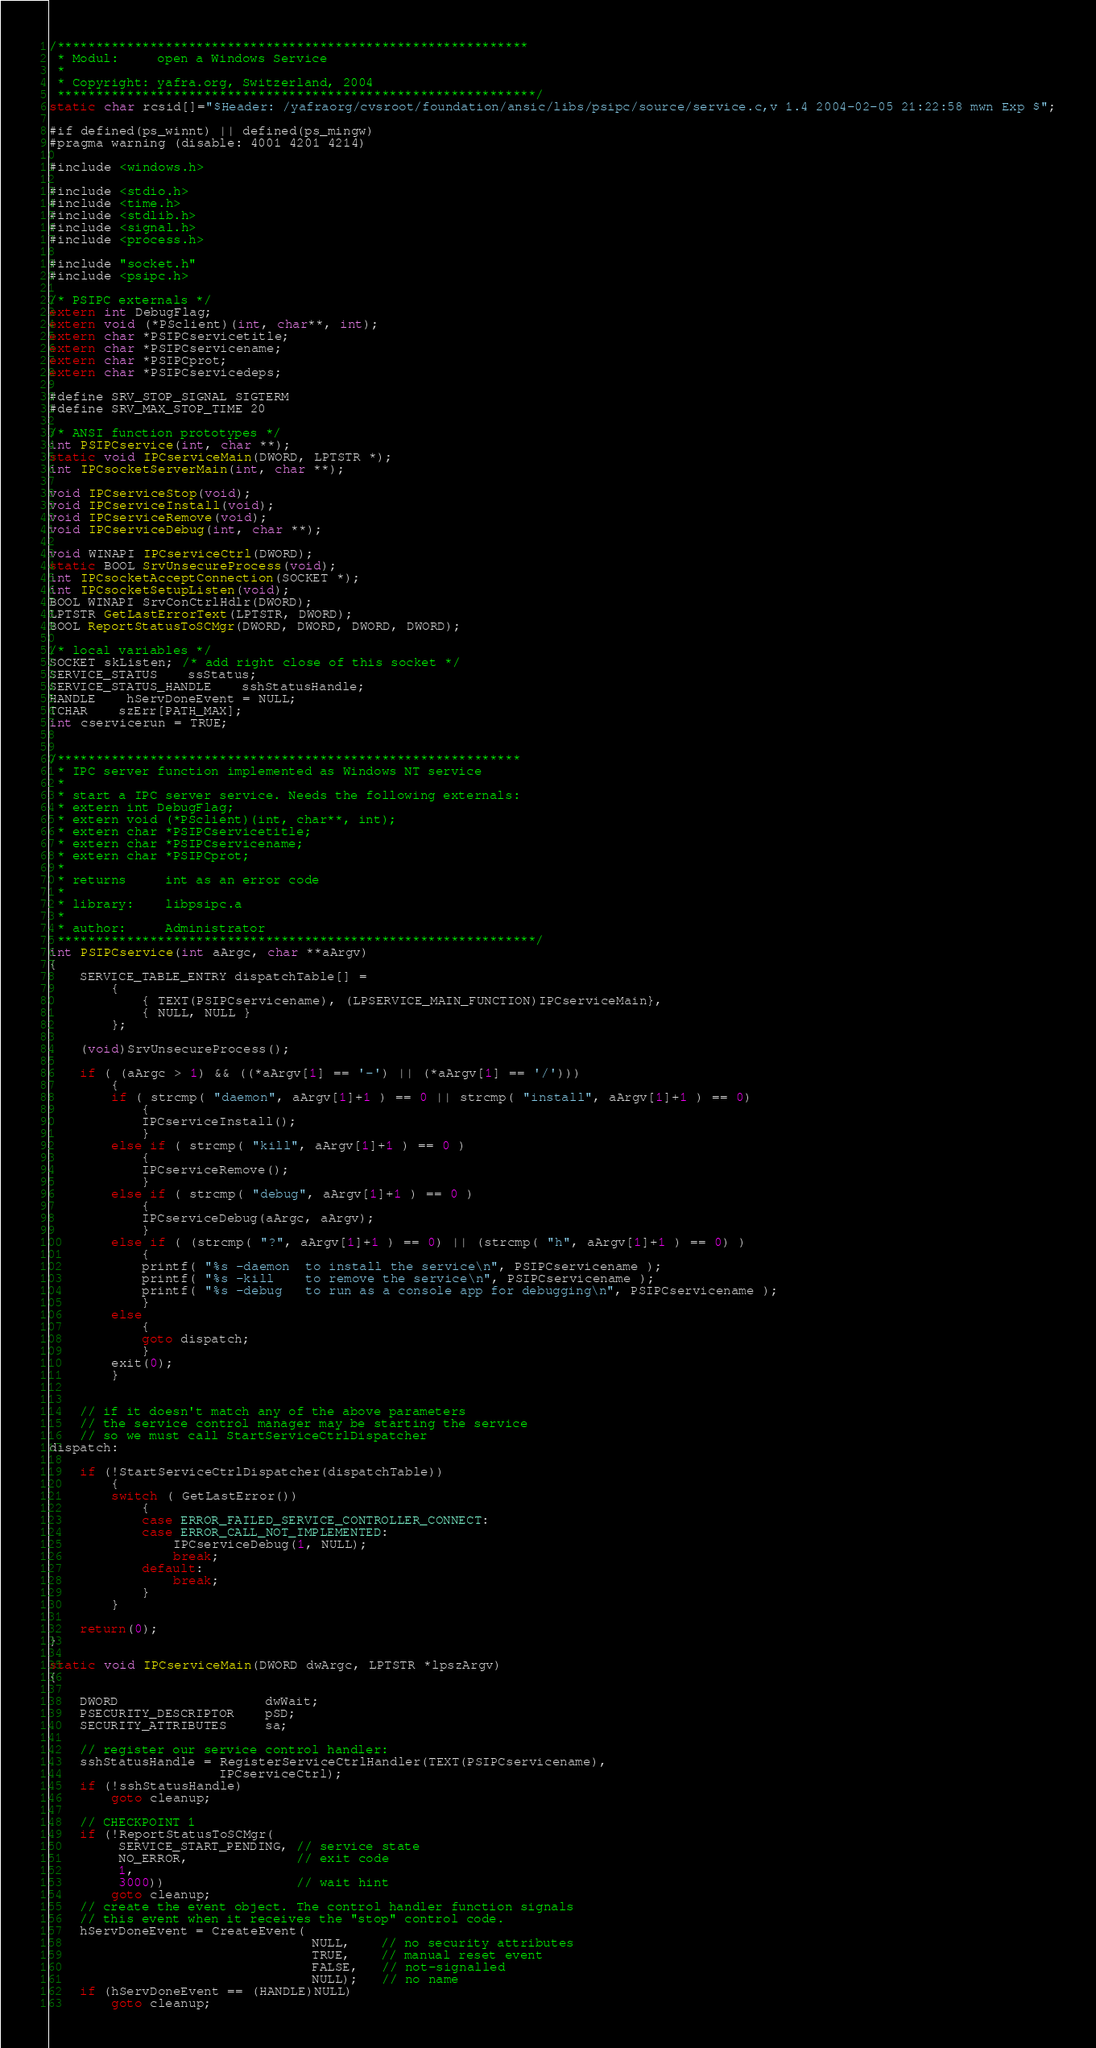Convert code to text. <code><loc_0><loc_0><loc_500><loc_500><_C_>/*************************************************************
 * Modul:     open a Windows Service
 *
 * Copyright: yafra.org, Switzerland, 2004
 **************************************************************/
static char rcsid[]="$Header: /yafraorg/cvsroot/foundation/ansic/libs/psipc/source/service.c,v 1.4 2004-02-05 21:22:58 mwn Exp $";

#if defined(ps_winnt) || defined(ps_mingw)
#pragma warning (disable: 4001 4201 4214)

#include <windows.h>

#include <stdio.h>
#include <time.h>
#include <stdlib.h>
#include <signal.h>
#include <process.h>

#include "socket.h"
#include <psipc.h>

/* PSIPC externals */
extern int DebugFlag;
extern void (*PSclient)(int, char**, int);
extern char *PSIPCservicetitle;
extern char *PSIPCservicename;
extern char *PSIPCprot;
extern char *PSIPCservicedeps;

#define SRV_STOP_SIGNAL SIGTERM
#define SRV_MAX_STOP_TIME 20

/* ANSI function prototypes */
int PSIPCservice(int, char **);
static void IPCserviceMain(DWORD, LPTSTR *);
int IPCsocketServerMain(int, char **);

void IPCserviceStop(void);
void IPCserviceInstall(void);
void IPCserviceRemove(void);
void IPCserviceDebug(int, char **);

void WINAPI IPCserviceCtrl(DWORD);
static BOOL SrvUnsecureProcess(void);
int IPCsocketAcceptConnection(SOCKET *);
int IPCsocketSetupListen(void);
BOOL WINAPI SrvConCtrlHdlr(DWORD);
LPTSTR GetLastErrorText(LPTSTR, DWORD);
BOOL ReportStatusToSCMgr(DWORD, DWORD, DWORD, DWORD);

/* local variables */
SOCKET skListen; /* add right close of this socket */
SERVICE_STATUS	ssStatus;
SERVICE_STATUS_HANDLE	sshStatusHandle;
HANDLE	hServDoneEvent = NULL;
TCHAR    szErr[PATH_MAX];
int cservicerun = TRUE;


/************************************************************
 * IPC server function implemented as Windows NT service
 *
 * start a IPC server service. Needs the following externals:
 * extern int DebugFlag;
 * extern void (*PSclient)(int, char**, int);
 * extern char *PSIPCservicetitle;
 * extern char *PSIPCservicename;
 * extern char *PSIPCprot;
 *
 * returns     int as an error code
 *
 * library:    libpsipc.a
 *
 * author:     Administrator
 **************************************************************/
int PSIPCservice(int aArgc, char **aArgv)
{
	SERVICE_TABLE_ENTRY dispatchTable[] =
		{
			{ TEXT(PSIPCservicename), (LPSERVICE_MAIN_FUNCTION)IPCserviceMain},
			{ NULL, NULL }
		};

	(void)SrvUnsecureProcess();

	if ( (aArgc > 1) && ((*aArgv[1] == '-') || (*aArgv[1] == '/')))
		{
		if ( strcmp( "daemon", aArgv[1]+1 ) == 0 || strcmp( "install", aArgv[1]+1 ) == 0)
			{
			IPCserviceInstall();
			}
		else if ( strcmp( "kill", aArgv[1]+1 ) == 0 )
			{
			IPCserviceRemove();
			}
		else if ( strcmp( "debug", aArgv[1]+1 ) == 0 )
			{
			IPCserviceDebug(aArgc, aArgv);
			}
		else if ( (strcmp( "?", aArgv[1]+1 ) == 0) || (strcmp( "h", aArgv[1]+1 ) == 0) )
			{
			printf( "%s -daemon  to install the service\n", PSIPCservicename );
			printf( "%s -kill    to remove the service\n", PSIPCservicename );
			printf( "%s -debug   to run as a console app for debugging\n", PSIPCservicename );
			}
		else
			{
			goto dispatch;
			}
		exit(0);
		}


	// if it doesn't match any of the above parameters
	// the service control manager may be starting the service
	// so we must call StartServiceCtrlDispatcher
dispatch:

	if (!StartServiceCtrlDispatcher(dispatchTable))
		{
 		switch ( GetLastError())
			{
			case ERROR_FAILED_SERVICE_CONTROLLER_CONNECT:
			case ERROR_CALL_NOT_IMPLEMENTED:
				IPCserviceDebug(1, NULL);
				break;
			default:
				break;
			}
		}

	return(0);
}

static void IPCserviceMain(DWORD dwArgc, LPTSTR *lpszArgv)
{

	DWORD                   dwWait;
	PSECURITY_DESCRIPTOR    pSD;
	SECURITY_ATTRIBUTES     sa;

	// register our service control handler:
	sshStatusHandle = RegisterServiceCtrlHandler(TEXT(PSIPCservicename),
	                  IPCserviceCtrl);
	if (!sshStatusHandle)
		goto cleanup;

	// CHECKPOINT 1
	if (!ReportStatusToSCMgr(
		 SERVICE_START_PENDING, // service state
		 NO_ERROR,              // exit code
		 1,
		 3000))                 // wait hint
		goto cleanup;
  	// create the event object. The control handler function signals
  	// this event when it receives the "stop" control code.
  	hServDoneEvent = CreateEvent(
								  NULL,    // no security attributes
								  TRUE,    // manual reset event
								  FALSE,   // not-signalled
								  NULL);   // no name
  	if (hServDoneEvent == (HANDLE)NULL)
     	goto cleanup;
</code> 